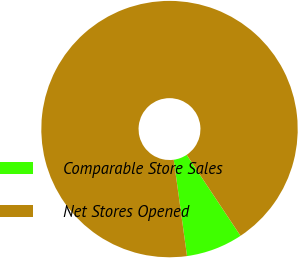<chart> <loc_0><loc_0><loc_500><loc_500><pie_chart><fcel>Comparable Store Sales<fcel>Net Stores Opened<nl><fcel>7.16%<fcel>92.84%<nl></chart> 